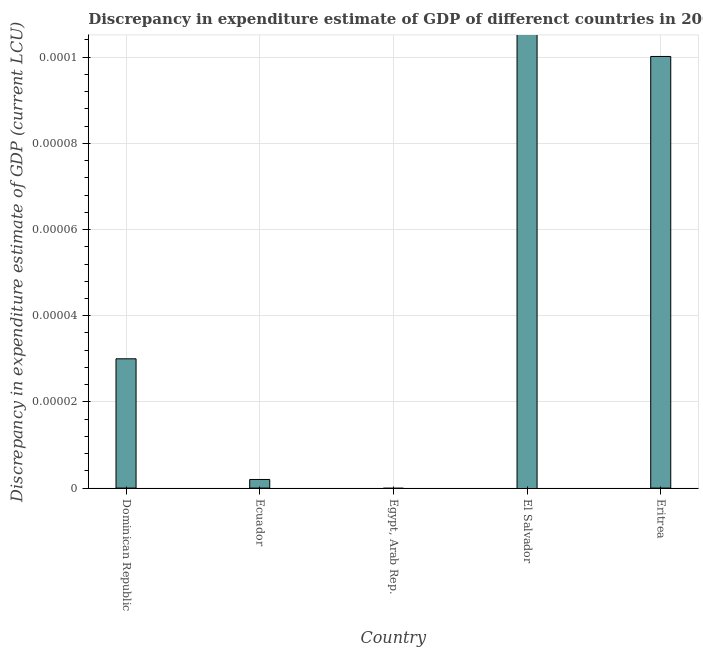Does the graph contain any zero values?
Ensure brevity in your answer.  Yes. Does the graph contain grids?
Make the answer very short. Yes. What is the title of the graph?
Give a very brief answer. Discrepancy in expenditure estimate of GDP of differenct countries in 2000. What is the label or title of the Y-axis?
Provide a short and direct response. Discrepancy in expenditure estimate of GDP (current LCU). What is the discrepancy in expenditure estimate of gdp in Eritrea?
Provide a short and direct response. 0. Across all countries, what is the maximum discrepancy in expenditure estimate of gdp?
Make the answer very short. 0. In which country was the discrepancy in expenditure estimate of gdp maximum?
Your answer should be very brief. Eritrea. What is the sum of the discrepancy in expenditure estimate of gdp?
Make the answer very short. 0. What is the median discrepancy in expenditure estimate of gdp?
Your response must be concise. 2e-6. What is the ratio of the discrepancy in expenditure estimate of gdp in Dominican Republic to that in Ecuador?
Offer a terse response. 15. Is the discrepancy in expenditure estimate of gdp in Dominican Republic less than that in Ecuador?
Make the answer very short. No. Is the difference between the discrepancy in expenditure estimate of gdp in Dominican Republic and Eritrea greater than the difference between any two countries?
Your response must be concise. No. What is the difference between the highest and the second highest discrepancy in expenditure estimate of gdp?
Provide a short and direct response. 0. What is the difference between the highest and the lowest discrepancy in expenditure estimate of gdp?
Your answer should be very brief. 0. How many countries are there in the graph?
Ensure brevity in your answer.  5. What is the difference between two consecutive major ticks on the Y-axis?
Keep it short and to the point. 2e-5. What is the Discrepancy in expenditure estimate of GDP (current LCU) in Dominican Republic?
Offer a terse response. 3e-5. What is the Discrepancy in expenditure estimate of GDP (current LCU) in Ecuador?
Keep it short and to the point. 2e-6. What is the Discrepancy in expenditure estimate of GDP (current LCU) of El Salvador?
Make the answer very short. 0. What is the Discrepancy in expenditure estimate of GDP (current LCU) in Eritrea?
Provide a short and direct response. 0. What is the difference between the Discrepancy in expenditure estimate of GDP (current LCU) in Dominican Republic and Ecuador?
Offer a very short reply. 3e-5. What is the difference between the Discrepancy in expenditure estimate of GDP (current LCU) in Dominican Republic and Eritrea?
Make the answer very short. -7e-5. What is the difference between the Discrepancy in expenditure estimate of GDP (current LCU) in Ecuador and Eritrea?
Your answer should be very brief. -0. 